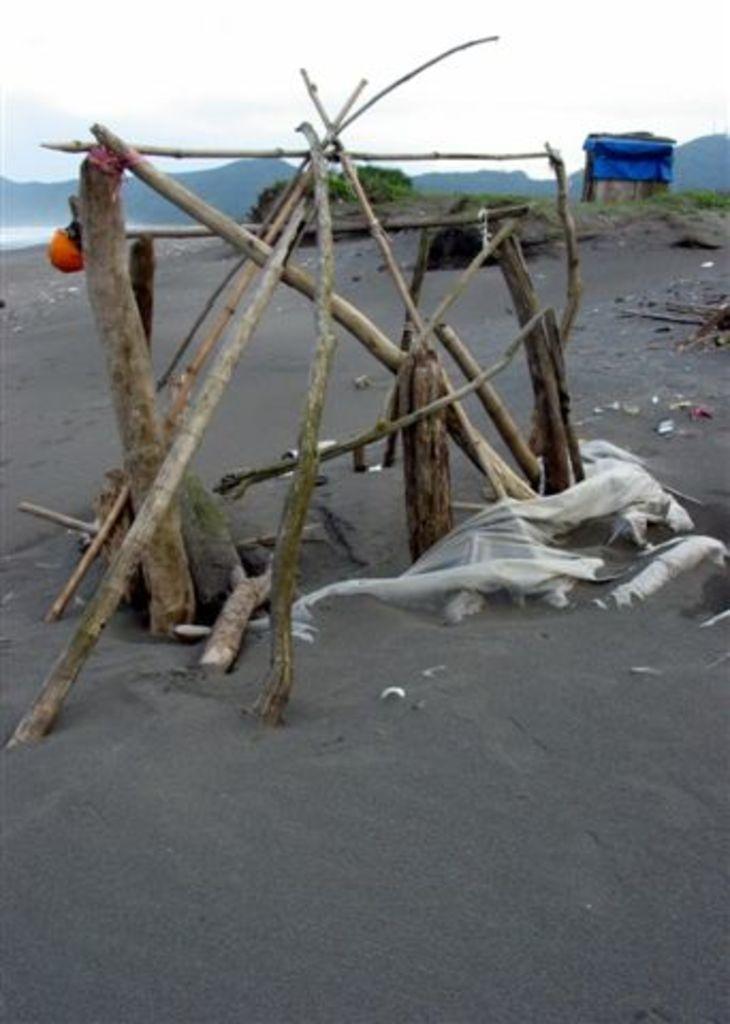Can you describe this image briefly? In this image I can see number of sticks and few clothes on the ground. In the background I can see grass and a blue colour thing. 